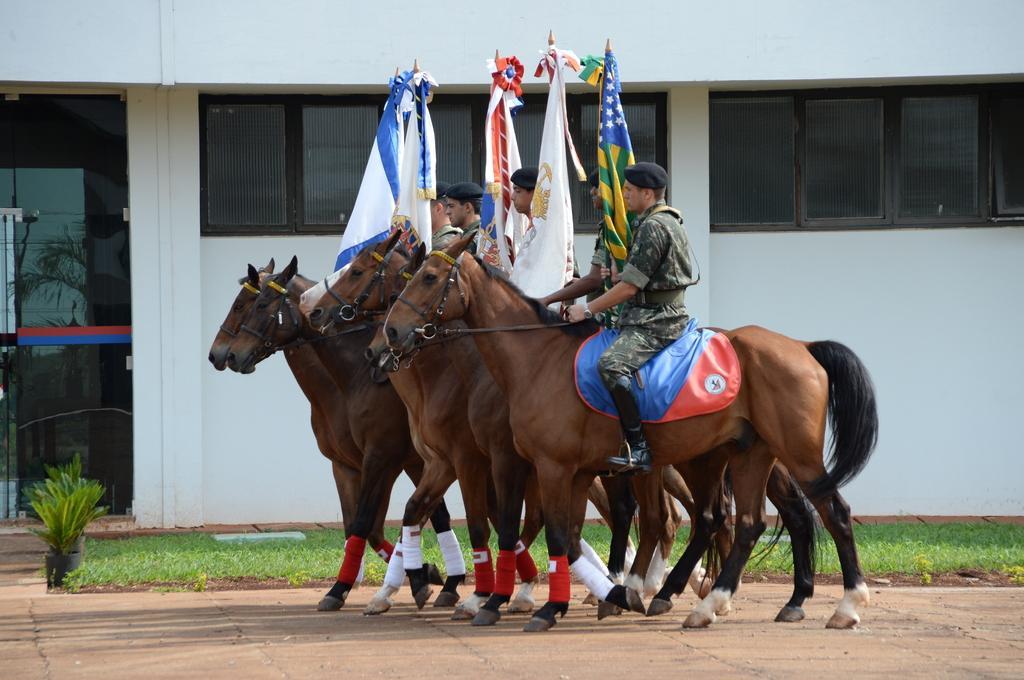Could you give a brief overview of what you see in this image? In the middle of the image few people are riding horses and holding flags. Behind them there is grass and plant. At the top of the image there is wall, on the wall there are some windows. 